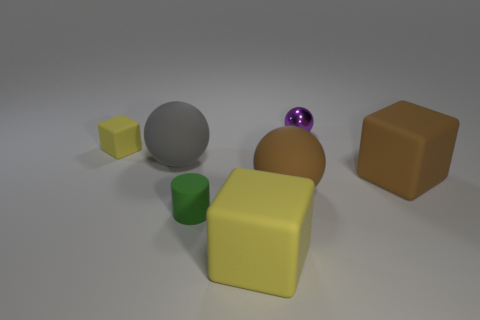Are there any other things that are the same size as the brown matte ball?
Give a very brief answer. Yes. How many other objects are the same shape as the big yellow rubber thing?
Offer a terse response. 2. Is the number of tiny yellow blocks on the right side of the purple thing greater than the number of big matte objects left of the large yellow block?
Your answer should be compact. No. There is a thing behind the tiny yellow rubber cube; does it have the same size as the rubber block that is in front of the brown matte cube?
Your answer should be very brief. No. What is the shape of the gray thing?
Offer a very short reply. Sphere. There is a matte thing that is the same color as the small matte cube; what is its size?
Your answer should be very brief. Large. What color is the big ball that is made of the same material as the gray thing?
Provide a short and direct response. Brown. Do the tiny sphere and the large sphere to the left of the large yellow matte block have the same material?
Provide a short and direct response. No. What color is the rubber cylinder?
Your answer should be compact. Green. The brown ball that is the same material as the tiny yellow cube is what size?
Give a very brief answer. Large. 